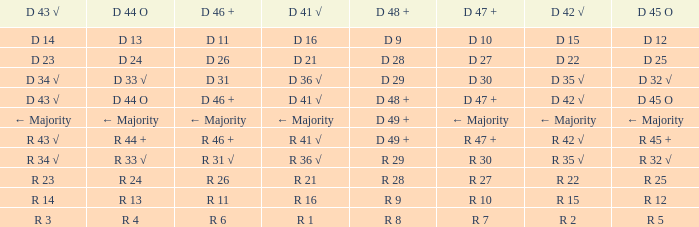What is the value of D 45 O, when the value of D 41 √ is r 41 √? R 45 +. 